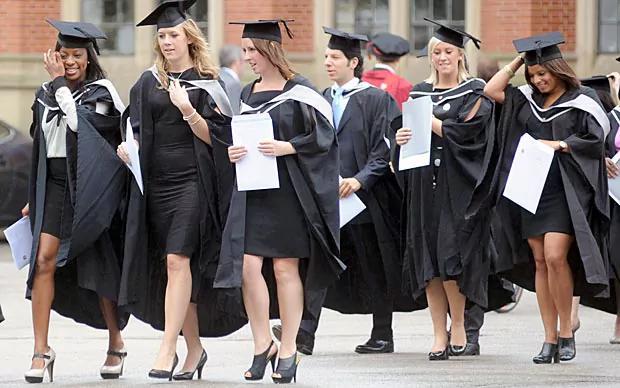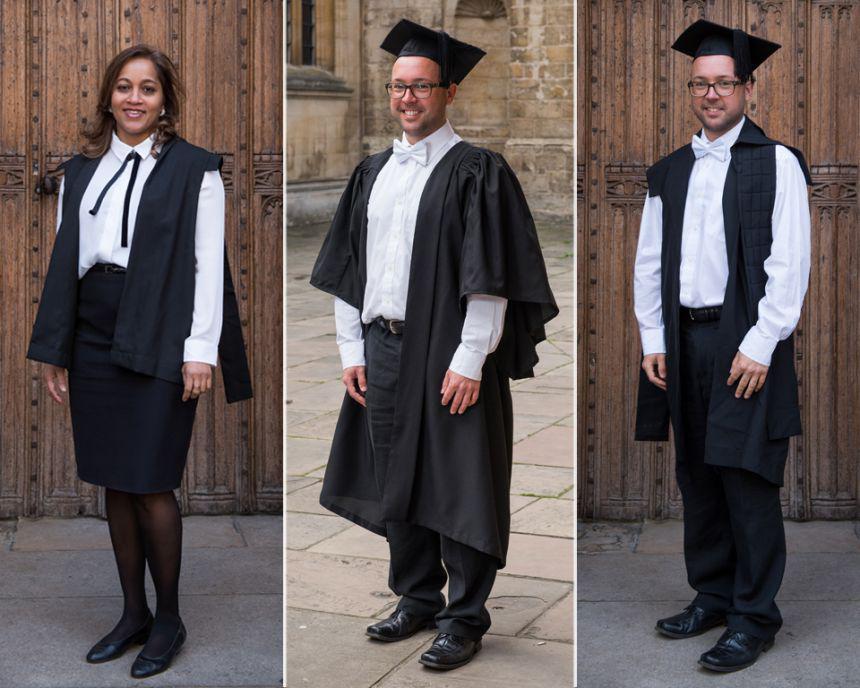The first image is the image on the left, the second image is the image on the right. Considering the images on both sides, is "The left image contains no more than four graduation students." valid? Answer yes or no. No. The first image is the image on the left, the second image is the image on the right. For the images displayed, is the sentence "In one image at least two male graduates are wearing white bow ties and at least one female graduate is wearing an untied black string tie and black hosiery." factually correct? Answer yes or no. Yes. 